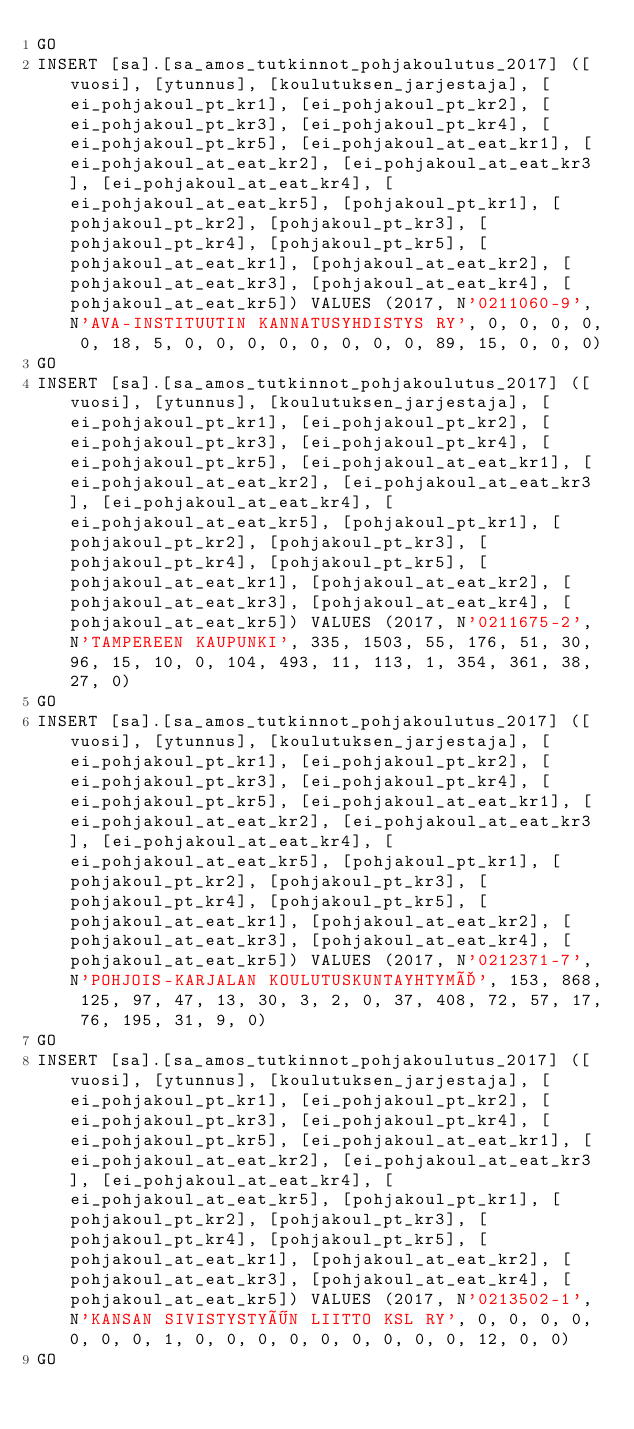Convert code to text. <code><loc_0><loc_0><loc_500><loc_500><_SQL_>GO
INSERT [sa].[sa_amos_tutkinnot_pohjakoulutus_2017] ([vuosi], [ytunnus], [koulutuksen_jarjestaja], [ei_pohjakoul_pt_kr1], [ei_pohjakoul_pt_kr2], [ei_pohjakoul_pt_kr3], [ei_pohjakoul_pt_kr4], [ei_pohjakoul_pt_kr5], [ei_pohjakoul_at_eat_kr1], [ei_pohjakoul_at_eat_kr2], [ei_pohjakoul_at_eat_kr3], [ei_pohjakoul_at_eat_kr4], [ei_pohjakoul_at_eat_kr5], [pohjakoul_pt_kr1], [pohjakoul_pt_kr2], [pohjakoul_pt_kr3], [pohjakoul_pt_kr4], [pohjakoul_pt_kr5], [pohjakoul_at_eat_kr1], [pohjakoul_at_eat_kr2], [pohjakoul_at_eat_kr3], [pohjakoul_at_eat_kr4], [pohjakoul_at_eat_kr5]) VALUES (2017, N'0211060-9', N'AVA-INSTITUUTIN KANNATUSYHDISTYS RY', 0, 0, 0, 0, 0, 18, 5, 0, 0, 0, 0, 0, 0, 0, 0, 89, 15, 0, 0, 0)
GO
INSERT [sa].[sa_amos_tutkinnot_pohjakoulutus_2017] ([vuosi], [ytunnus], [koulutuksen_jarjestaja], [ei_pohjakoul_pt_kr1], [ei_pohjakoul_pt_kr2], [ei_pohjakoul_pt_kr3], [ei_pohjakoul_pt_kr4], [ei_pohjakoul_pt_kr5], [ei_pohjakoul_at_eat_kr1], [ei_pohjakoul_at_eat_kr2], [ei_pohjakoul_at_eat_kr3], [ei_pohjakoul_at_eat_kr4], [ei_pohjakoul_at_eat_kr5], [pohjakoul_pt_kr1], [pohjakoul_pt_kr2], [pohjakoul_pt_kr3], [pohjakoul_pt_kr4], [pohjakoul_pt_kr5], [pohjakoul_at_eat_kr1], [pohjakoul_at_eat_kr2], [pohjakoul_at_eat_kr3], [pohjakoul_at_eat_kr4], [pohjakoul_at_eat_kr5]) VALUES (2017, N'0211675-2', N'TAMPEREEN KAUPUNKI', 335, 1503, 55, 176, 51, 30, 96, 15, 10, 0, 104, 493, 11, 113, 1, 354, 361, 38, 27, 0)
GO
INSERT [sa].[sa_amos_tutkinnot_pohjakoulutus_2017] ([vuosi], [ytunnus], [koulutuksen_jarjestaja], [ei_pohjakoul_pt_kr1], [ei_pohjakoul_pt_kr2], [ei_pohjakoul_pt_kr3], [ei_pohjakoul_pt_kr4], [ei_pohjakoul_pt_kr5], [ei_pohjakoul_at_eat_kr1], [ei_pohjakoul_at_eat_kr2], [ei_pohjakoul_at_eat_kr3], [ei_pohjakoul_at_eat_kr4], [ei_pohjakoul_at_eat_kr5], [pohjakoul_pt_kr1], [pohjakoul_pt_kr2], [pohjakoul_pt_kr3], [pohjakoul_pt_kr4], [pohjakoul_pt_kr5], [pohjakoul_at_eat_kr1], [pohjakoul_at_eat_kr2], [pohjakoul_at_eat_kr3], [pohjakoul_at_eat_kr4], [pohjakoul_at_eat_kr5]) VALUES (2017, N'0212371-7', N'POHJOIS-KARJALAN KOULUTUSKUNTAYHTYMÄ', 153, 868, 125, 97, 47, 13, 30, 3, 2, 0, 37, 408, 72, 57, 17, 76, 195, 31, 9, 0)
GO
INSERT [sa].[sa_amos_tutkinnot_pohjakoulutus_2017] ([vuosi], [ytunnus], [koulutuksen_jarjestaja], [ei_pohjakoul_pt_kr1], [ei_pohjakoul_pt_kr2], [ei_pohjakoul_pt_kr3], [ei_pohjakoul_pt_kr4], [ei_pohjakoul_pt_kr5], [ei_pohjakoul_at_eat_kr1], [ei_pohjakoul_at_eat_kr2], [ei_pohjakoul_at_eat_kr3], [ei_pohjakoul_at_eat_kr4], [ei_pohjakoul_at_eat_kr5], [pohjakoul_pt_kr1], [pohjakoul_pt_kr2], [pohjakoul_pt_kr3], [pohjakoul_pt_kr4], [pohjakoul_pt_kr5], [pohjakoul_at_eat_kr1], [pohjakoul_at_eat_kr2], [pohjakoul_at_eat_kr3], [pohjakoul_at_eat_kr4], [pohjakoul_at_eat_kr5]) VALUES (2017, N'0213502-1', N'KANSAN SIVISTYSTYÖN LIITTO KSL RY', 0, 0, 0, 0, 0, 0, 0, 1, 0, 0, 0, 0, 0, 0, 0, 0, 0, 12, 0, 0)
GO</code> 